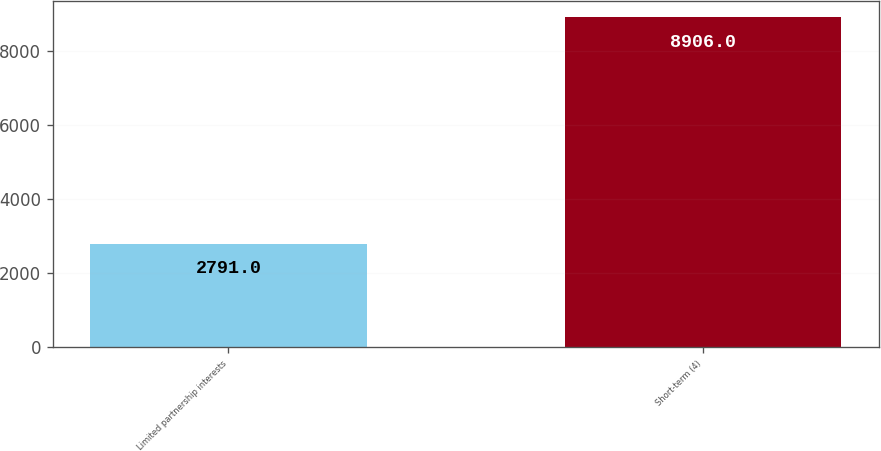<chart> <loc_0><loc_0><loc_500><loc_500><bar_chart><fcel>Limited partnership interests<fcel>Short-term (4)<nl><fcel>2791<fcel>8906<nl></chart> 